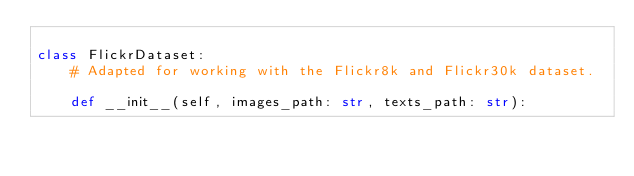Convert code to text. <code><loc_0><loc_0><loc_500><loc_500><_Python_>
class FlickrDataset:
    # Adapted for working with the Flickr8k and Flickr30k dataset.

    def __init__(self, images_path: str, texts_path: str):</code> 